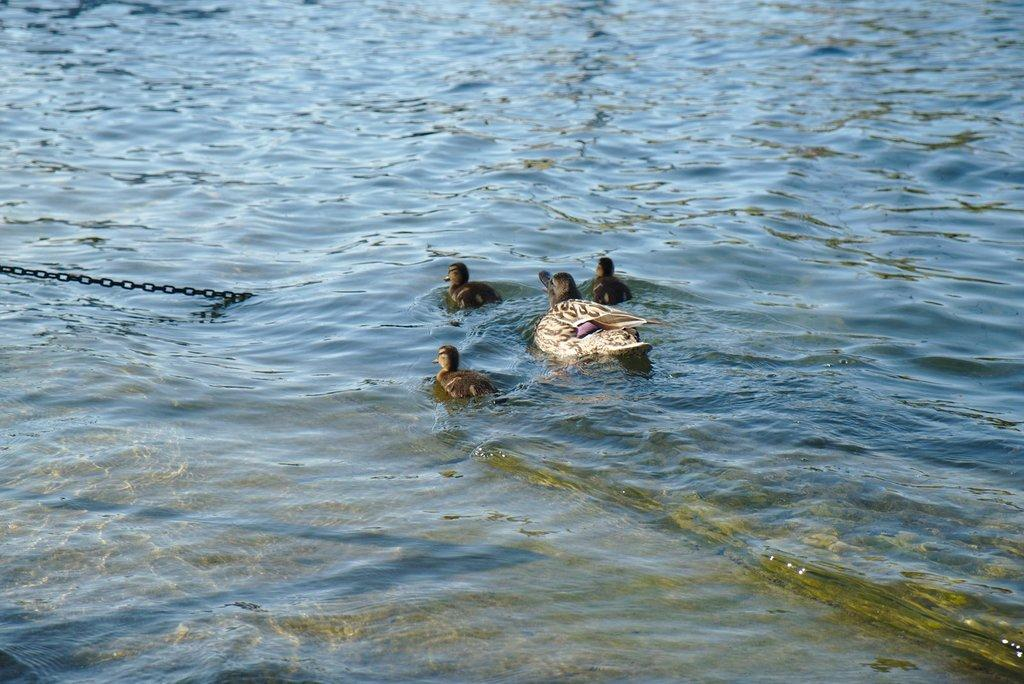What type of animal can be seen in the image? There is a duck in the image. Are there any other animals present in the image? Yes, there are ducklings in the image. What are the duck and ducklings doing in the image? The duck and ducklings are swimming in water. What type of bead is being used to control the duck's movements in the image? A: There is no bead present in the image, nor is there any indication that the duck's movements are being controlled. 